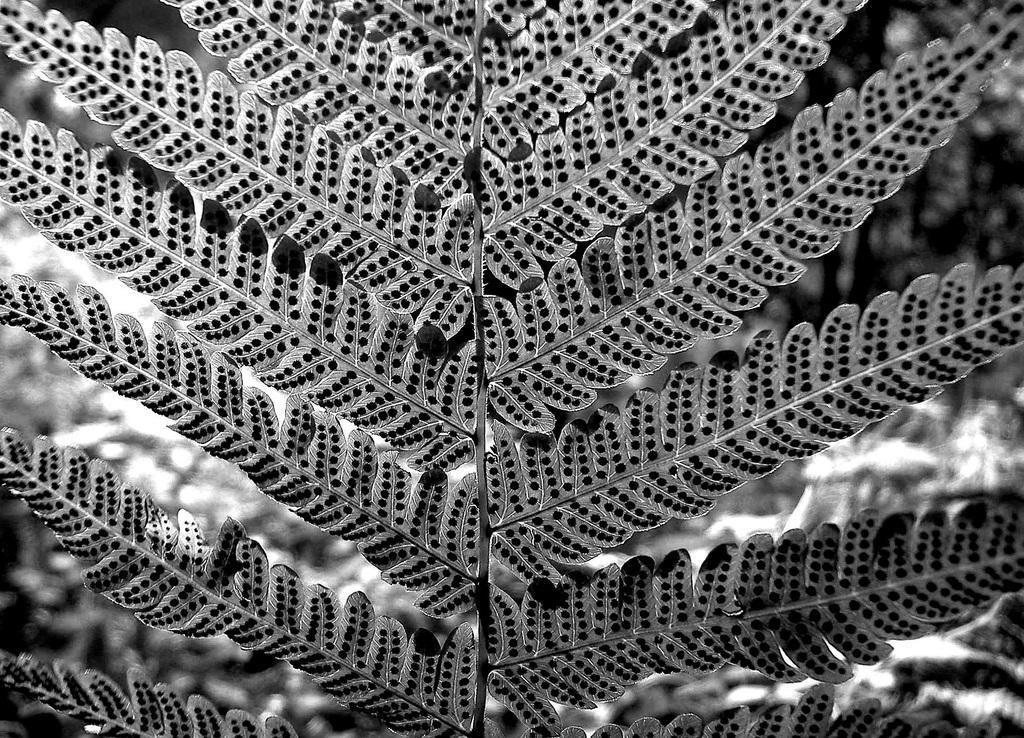How would you summarize this image in a sentence or two? This is a black and white image as we can see leaves and a stem. 